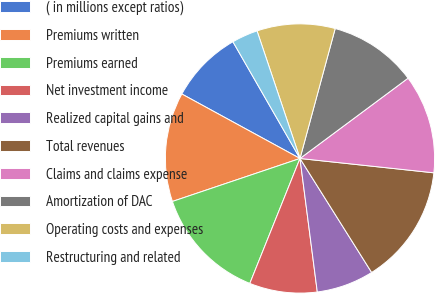Convert chart. <chart><loc_0><loc_0><loc_500><loc_500><pie_chart><fcel>( in millions except ratios)<fcel>Premiums written<fcel>Premiums earned<fcel>Net investment income<fcel>Realized capital gains and<fcel>Total revenues<fcel>Claims and claims expense<fcel>Amortization of DAC<fcel>Operating costs and expenses<fcel>Restructuring and related<nl><fcel>8.75%<fcel>13.12%<fcel>13.75%<fcel>8.13%<fcel>6.88%<fcel>14.37%<fcel>11.87%<fcel>10.62%<fcel>9.38%<fcel>3.13%<nl></chart> 